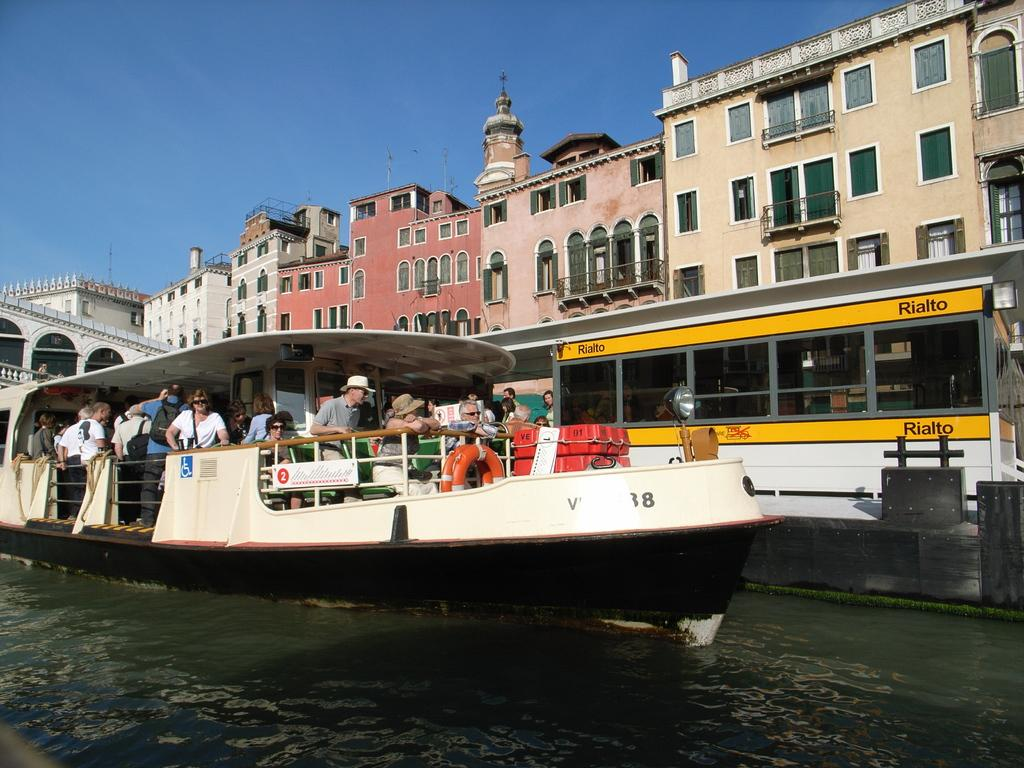What is located on the left side of the image? There is a ship in the water on the left side of the image. What can be seen inside the ship? There are people standing in the ship. What type of structures are in the middle of the image? There are large buildings in the middle of the image. What is visible at the top of the image? The sky is visible at the top of the image. Where is the scarecrow standing in the image? There is no scarecrow present in the image. What type of authority is depicted in the image? The image does not depict any authority figures; it features a ship, people, buildings, and the sky. 